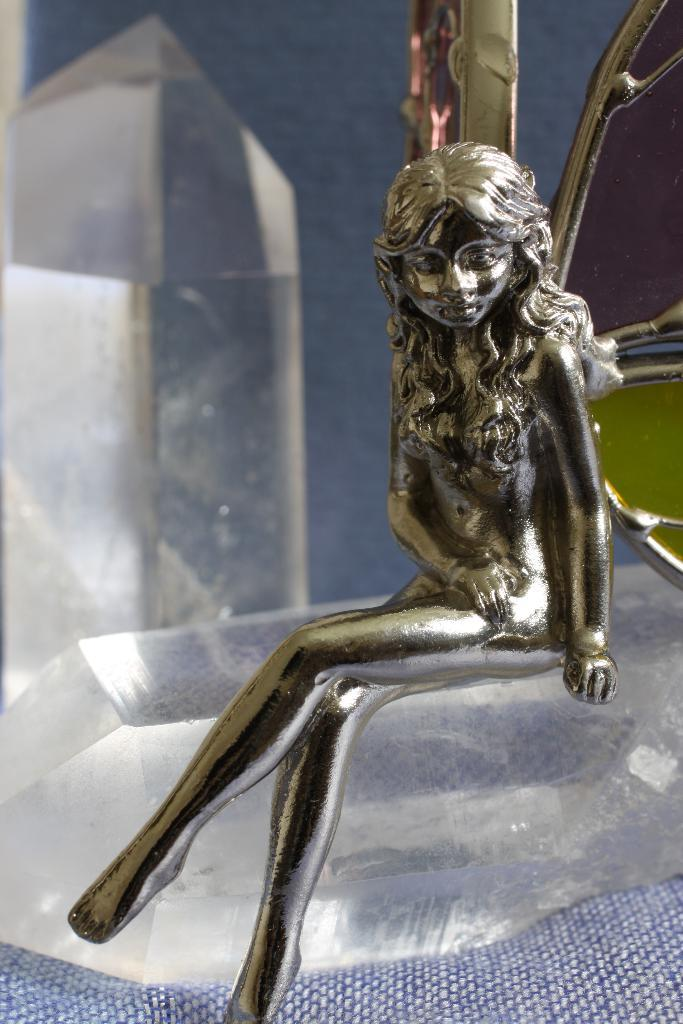What is the main subject in the image? There is a statue in the image. Can you describe any other objects in the image besides the statue? Yes, there are objects in the image. What type of flower is being held by the maid in the image? There is no maid or flower present in the image; it only features a statue and other objects. 